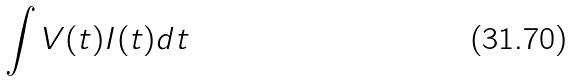<formula> <loc_0><loc_0><loc_500><loc_500>\int V ( t ) I ( t ) d t</formula> 